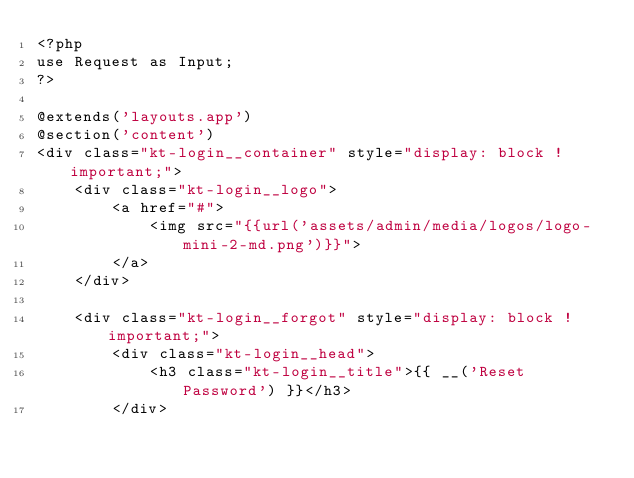<code> <loc_0><loc_0><loc_500><loc_500><_PHP_><?php
use Request as Input;
?>

@extends('layouts.app')
@section('content')
<div class="kt-login__container" style="display: block !important;">    
    <div class="kt-login__logo">
        <a href="#">
            <img src="{{url('assets/admin/media/logos/logo-mini-2-md.png')}}">
        </a>
    </div>   

    <div class="kt-login__forgot" style="display: block !important;">
        <div class="kt-login__head">
            <h3 class="kt-login__title">{{ __('Reset Password') }}</h3>            
        </div>         </code> 